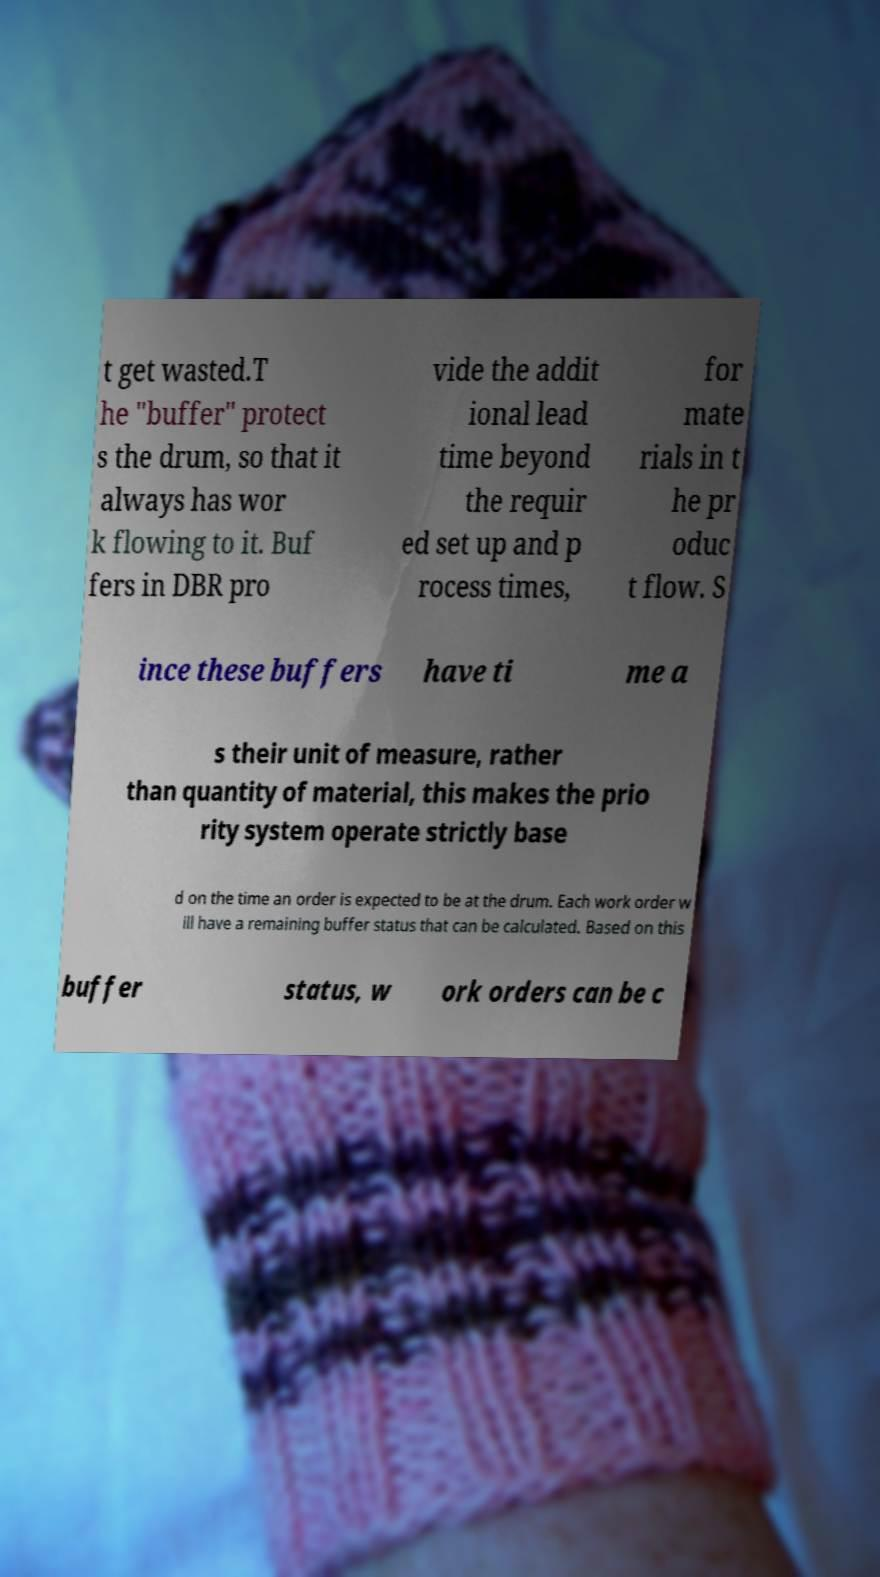Please identify and transcribe the text found in this image. t get wasted.T he "buffer" protect s the drum, so that it always has wor k flowing to it. Buf fers in DBR pro vide the addit ional lead time beyond the requir ed set up and p rocess times, for mate rials in t he pr oduc t flow. S ince these buffers have ti me a s their unit of measure, rather than quantity of material, this makes the prio rity system operate strictly base d on the time an order is expected to be at the drum. Each work order w ill have a remaining buffer status that can be calculated. Based on this buffer status, w ork orders can be c 